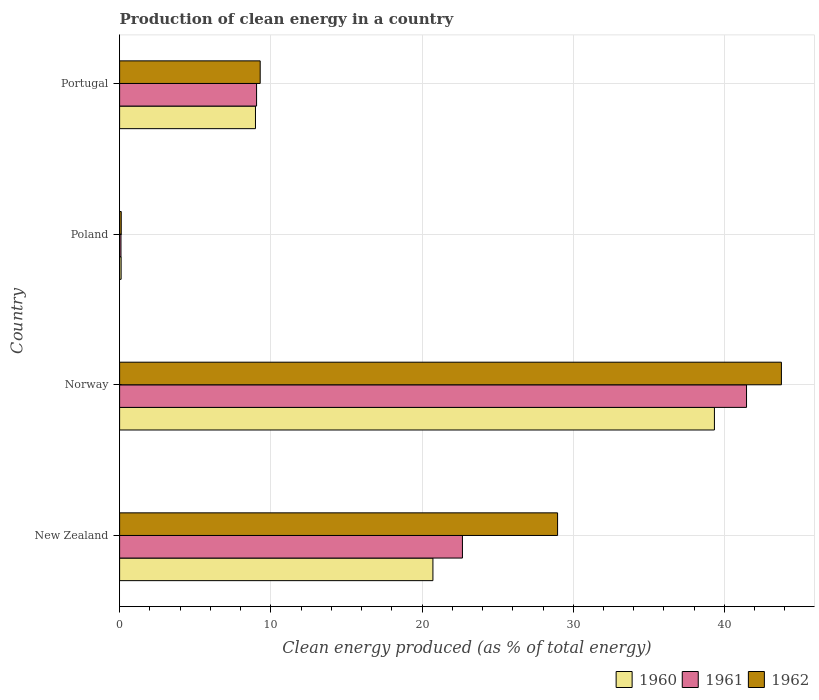How many different coloured bars are there?
Your response must be concise. 3. How many groups of bars are there?
Provide a succinct answer. 4. How many bars are there on the 4th tick from the top?
Your answer should be compact. 3. How many bars are there on the 3rd tick from the bottom?
Give a very brief answer. 3. What is the label of the 2nd group of bars from the top?
Keep it short and to the point. Poland. In how many cases, is the number of bars for a given country not equal to the number of legend labels?
Give a very brief answer. 0. What is the percentage of clean energy produced in 1961 in Norway?
Provide a succinct answer. 41.46. Across all countries, what is the maximum percentage of clean energy produced in 1962?
Provide a succinct answer. 43.77. Across all countries, what is the minimum percentage of clean energy produced in 1960?
Your response must be concise. 0.1. In which country was the percentage of clean energy produced in 1960 maximum?
Give a very brief answer. Norway. What is the total percentage of clean energy produced in 1962 in the graph?
Give a very brief answer. 82.13. What is the difference between the percentage of clean energy produced in 1960 in New Zealand and that in Portugal?
Your response must be concise. 11.74. What is the difference between the percentage of clean energy produced in 1961 in New Zealand and the percentage of clean energy produced in 1960 in Norway?
Your answer should be very brief. -16.66. What is the average percentage of clean energy produced in 1960 per country?
Provide a short and direct response. 17.29. What is the difference between the percentage of clean energy produced in 1962 and percentage of clean energy produced in 1961 in Portugal?
Offer a terse response. 0.24. What is the ratio of the percentage of clean energy produced in 1961 in New Zealand to that in Portugal?
Make the answer very short. 2.5. What is the difference between the highest and the second highest percentage of clean energy produced in 1962?
Offer a terse response. 14.8. What is the difference between the highest and the lowest percentage of clean energy produced in 1962?
Ensure brevity in your answer.  43.66. In how many countries, is the percentage of clean energy produced in 1960 greater than the average percentage of clean energy produced in 1960 taken over all countries?
Give a very brief answer. 2. Is the sum of the percentage of clean energy produced in 1962 in Norway and Poland greater than the maximum percentage of clean energy produced in 1961 across all countries?
Ensure brevity in your answer.  Yes. What does the 3rd bar from the bottom in Poland represents?
Keep it short and to the point. 1962. Are all the bars in the graph horizontal?
Provide a short and direct response. Yes. How many countries are there in the graph?
Make the answer very short. 4. How many legend labels are there?
Offer a terse response. 3. What is the title of the graph?
Provide a succinct answer. Production of clean energy in a country. Does "1999" appear as one of the legend labels in the graph?
Make the answer very short. No. What is the label or title of the X-axis?
Give a very brief answer. Clean energy produced (as % of total energy). What is the Clean energy produced (as % of total energy) of 1960 in New Zealand?
Your response must be concise. 20.72. What is the Clean energy produced (as % of total energy) in 1961 in New Zealand?
Keep it short and to the point. 22.67. What is the Clean energy produced (as % of total energy) in 1962 in New Zealand?
Make the answer very short. 28.96. What is the Clean energy produced (as % of total energy) of 1960 in Norway?
Your answer should be compact. 39.34. What is the Clean energy produced (as % of total energy) in 1961 in Norway?
Keep it short and to the point. 41.46. What is the Clean energy produced (as % of total energy) in 1962 in Norway?
Your answer should be compact. 43.77. What is the Clean energy produced (as % of total energy) in 1960 in Poland?
Your answer should be compact. 0.1. What is the Clean energy produced (as % of total energy) in 1961 in Poland?
Your answer should be compact. 0.09. What is the Clean energy produced (as % of total energy) in 1962 in Poland?
Keep it short and to the point. 0.11. What is the Clean energy produced (as % of total energy) in 1960 in Portugal?
Offer a very short reply. 8.99. What is the Clean energy produced (as % of total energy) of 1961 in Portugal?
Provide a succinct answer. 9.06. What is the Clean energy produced (as % of total energy) of 1962 in Portugal?
Provide a short and direct response. 9.3. Across all countries, what is the maximum Clean energy produced (as % of total energy) in 1960?
Make the answer very short. 39.34. Across all countries, what is the maximum Clean energy produced (as % of total energy) of 1961?
Keep it short and to the point. 41.46. Across all countries, what is the maximum Clean energy produced (as % of total energy) of 1962?
Provide a short and direct response. 43.77. Across all countries, what is the minimum Clean energy produced (as % of total energy) in 1960?
Ensure brevity in your answer.  0.1. Across all countries, what is the minimum Clean energy produced (as % of total energy) of 1961?
Provide a succinct answer. 0.09. Across all countries, what is the minimum Clean energy produced (as % of total energy) of 1962?
Make the answer very short. 0.11. What is the total Clean energy produced (as % of total energy) in 1960 in the graph?
Your response must be concise. 69.14. What is the total Clean energy produced (as % of total energy) in 1961 in the graph?
Your answer should be compact. 73.28. What is the total Clean energy produced (as % of total energy) of 1962 in the graph?
Give a very brief answer. 82.13. What is the difference between the Clean energy produced (as % of total energy) in 1960 in New Zealand and that in Norway?
Offer a terse response. -18.62. What is the difference between the Clean energy produced (as % of total energy) in 1961 in New Zealand and that in Norway?
Offer a very short reply. -18.79. What is the difference between the Clean energy produced (as % of total energy) in 1962 in New Zealand and that in Norway?
Give a very brief answer. -14.8. What is the difference between the Clean energy produced (as % of total energy) in 1960 in New Zealand and that in Poland?
Your response must be concise. 20.62. What is the difference between the Clean energy produced (as % of total energy) of 1961 in New Zealand and that in Poland?
Keep it short and to the point. 22.58. What is the difference between the Clean energy produced (as % of total energy) in 1962 in New Zealand and that in Poland?
Your answer should be compact. 28.86. What is the difference between the Clean energy produced (as % of total energy) of 1960 in New Zealand and that in Portugal?
Make the answer very short. 11.74. What is the difference between the Clean energy produced (as % of total energy) in 1961 in New Zealand and that in Portugal?
Offer a very short reply. 13.61. What is the difference between the Clean energy produced (as % of total energy) in 1962 in New Zealand and that in Portugal?
Provide a succinct answer. 19.67. What is the difference between the Clean energy produced (as % of total energy) in 1960 in Norway and that in Poland?
Ensure brevity in your answer.  39.24. What is the difference between the Clean energy produced (as % of total energy) of 1961 in Norway and that in Poland?
Give a very brief answer. 41.37. What is the difference between the Clean energy produced (as % of total energy) of 1962 in Norway and that in Poland?
Your response must be concise. 43.66. What is the difference between the Clean energy produced (as % of total energy) of 1960 in Norway and that in Portugal?
Keep it short and to the point. 30.35. What is the difference between the Clean energy produced (as % of total energy) in 1961 in Norway and that in Portugal?
Give a very brief answer. 32.4. What is the difference between the Clean energy produced (as % of total energy) in 1962 in Norway and that in Portugal?
Provide a short and direct response. 34.47. What is the difference between the Clean energy produced (as % of total energy) in 1960 in Poland and that in Portugal?
Offer a terse response. -8.88. What is the difference between the Clean energy produced (as % of total energy) of 1961 in Poland and that in Portugal?
Provide a short and direct response. -8.97. What is the difference between the Clean energy produced (as % of total energy) of 1962 in Poland and that in Portugal?
Make the answer very short. -9.19. What is the difference between the Clean energy produced (as % of total energy) of 1960 in New Zealand and the Clean energy produced (as % of total energy) of 1961 in Norway?
Provide a short and direct response. -20.74. What is the difference between the Clean energy produced (as % of total energy) in 1960 in New Zealand and the Clean energy produced (as % of total energy) in 1962 in Norway?
Offer a terse response. -23.05. What is the difference between the Clean energy produced (as % of total energy) in 1961 in New Zealand and the Clean energy produced (as % of total energy) in 1962 in Norway?
Make the answer very short. -21.09. What is the difference between the Clean energy produced (as % of total energy) of 1960 in New Zealand and the Clean energy produced (as % of total energy) of 1961 in Poland?
Your answer should be compact. 20.63. What is the difference between the Clean energy produced (as % of total energy) in 1960 in New Zealand and the Clean energy produced (as % of total energy) in 1962 in Poland?
Provide a short and direct response. 20.61. What is the difference between the Clean energy produced (as % of total energy) in 1961 in New Zealand and the Clean energy produced (as % of total energy) in 1962 in Poland?
Give a very brief answer. 22.56. What is the difference between the Clean energy produced (as % of total energy) in 1960 in New Zealand and the Clean energy produced (as % of total energy) in 1961 in Portugal?
Provide a succinct answer. 11.66. What is the difference between the Clean energy produced (as % of total energy) in 1960 in New Zealand and the Clean energy produced (as % of total energy) in 1962 in Portugal?
Offer a terse response. 11.42. What is the difference between the Clean energy produced (as % of total energy) of 1961 in New Zealand and the Clean energy produced (as % of total energy) of 1962 in Portugal?
Offer a terse response. 13.38. What is the difference between the Clean energy produced (as % of total energy) of 1960 in Norway and the Clean energy produced (as % of total energy) of 1961 in Poland?
Keep it short and to the point. 39.24. What is the difference between the Clean energy produced (as % of total energy) in 1960 in Norway and the Clean energy produced (as % of total energy) in 1962 in Poland?
Make the answer very short. 39.23. What is the difference between the Clean energy produced (as % of total energy) in 1961 in Norway and the Clean energy produced (as % of total energy) in 1962 in Poland?
Provide a short and direct response. 41.35. What is the difference between the Clean energy produced (as % of total energy) in 1960 in Norway and the Clean energy produced (as % of total energy) in 1961 in Portugal?
Your answer should be very brief. 30.28. What is the difference between the Clean energy produced (as % of total energy) in 1960 in Norway and the Clean energy produced (as % of total energy) in 1962 in Portugal?
Give a very brief answer. 30.04. What is the difference between the Clean energy produced (as % of total energy) of 1961 in Norway and the Clean energy produced (as % of total energy) of 1962 in Portugal?
Ensure brevity in your answer.  32.16. What is the difference between the Clean energy produced (as % of total energy) of 1960 in Poland and the Clean energy produced (as % of total energy) of 1961 in Portugal?
Provide a short and direct response. -8.96. What is the difference between the Clean energy produced (as % of total energy) of 1960 in Poland and the Clean energy produced (as % of total energy) of 1962 in Portugal?
Your answer should be very brief. -9.2. What is the difference between the Clean energy produced (as % of total energy) of 1961 in Poland and the Clean energy produced (as % of total energy) of 1962 in Portugal?
Make the answer very short. -9.21. What is the average Clean energy produced (as % of total energy) of 1960 per country?
Ensure brevity in your answer.  17.29. What is the average Clean energy produced (as % of total energy) in 1961 per country?
Make the answer very short. 18.32. What is the average Clean energy produced (as % of total energy) in 1962 per country?
Give a very brief answer. 20.53. What is the difference between the Clean energy produced (as % of total energy) in 1960 and Clean energy produced (as % of total energy) in 1961 in New Zealand?
Offer a very short reply. -1.95. What is the difference between the Clean energy produced (as % of total energy) of 1960 and Clean energy produced (as % of total energy) of 1962 in New Zealand?
Give a very brief answer. -8.24. What is the difference between the Clean energy produced (as % of total energy) in 1961 and Clean energy produced (as % of total energy) in 1962 in New Zealand?
Offer a terse response. -6.29. What is the difference between the Clean energy produced (as % of total energy) in 1960 and Clean energy produced (as % of total energy) in 1961 in Norway?
Keep it short and to the point. -2.12. What is the difference between the Clean energy produced (as % of total energy) in 1960 and Clean energy produced (as % of total energy) in 1962 in Norway?
Offer a terse response. -4.43. What is the difference between the Clean energy produced (as % of total energy) of 1961 and Clean energy produced (as % of total energy) of 1962 in Norway?
Your answer should be very brief. -2.31. What is the difference between the Clean energy produced (as % of total energy) in 1960 and Clean energy produced (as % of total energy) in 1961 in Poland?
Provide a short and direct response. 0.01. What is the difference between the Clean energy produced (as % of total energy) of 1960 and Clean energy produced (as % of total energy) of 1962 in Poland?
Keep it short and to the point. -0.01. What is the difference between the Clean energy produced (as % of total energy) of 1961 and Clean energy produced (as % of total energy) of 1962 in Poland?
Your answer should be very brief. -0.02. What is the difference between the Clean energy produced (as % of total energy) in 1960 and Clean energy produced (as % of total energy) in 1961 in Portugal?
Make the answer very short. -0.07. What is the difference between the Clean energy produced (as % of total energy) of 1960 and Clean energy produced (as % of total energy) of 1962 in Portugal?
Offer a terse response. -0.31. What is the difference between the Clean energy produced (as % of total energy) in 1961 and Clean energy produced (as % of total energy) in 1962 in Portugal?
Your answer should be compact. -0.24. What is the ratio of the Clean energy produced (as % of total energy) of 1960 in New Zealand to that in Norway?
Ensure brevity in your answer.  0.53. What is the ratio of the Clean energy produced (as % of total energy) of 1961 in New Zealand to that in Norway?
Provide a succinct answer. 0.55. What is the ratio of the Clean energy produced (as % of total energy) in 1962 in New Zealand to that in Norway?
Your response must be concise. 0.66. What is the ratio of the Clean energy produced (as % of total energy) of 1960 in New Zealand to that in Poland?
Give a very brief answer. 206.53. What is the ratio of the Clean energy produced (as % of total energy) in 1961 in New Zealand to that in Poland?
Your answer should be very brief. 247.72. What is the ratio of the Clean energy produced (as % of total energy) of 1962 in New Zealand to that in Poland?
Your answer should be very brief. 267.62. What is the ratio of the Clean energy produced (as % of total energy) of 1960 in New Zealand to that in Portugal?
Make the answer very short. 2.31. What is the ratio of the Clean energy produced (as % of total energy) in 1961 in New Zealand to that in Portugal?
Keep it short and to the point. 2.5. What is the ratio of the Clean energy produced (as % of total energy) in 1962 in New Zealand to that in Portugal?
Your answer should be compact. 3.12. What is the ratio of the Clean energy produced (as % of total energy) of 1960 in Norway to that in Poland?
Provide a short and direct response. 392.08. What is the ratio of the Clean energy produced (as % of total energy) in 1961 in Norway to that in Poland?
Offer a very short reply. 452.99. What is the ratio of the Clean energy produced (as % of total energy) in 1962 in Norway to that in Poland?
Ensure brevity in your answer.  404.39. What is the ratio of the Clean energy produced (as % of total energy) in 1960 in Norway to that in Portugal?
Your answer should be very brief. 4.38. What is the ratio of the Clean energy produced (as % of total energy) of 1961 in Norway to that in Portugal?
Keep it short and to the point. 4.58. What is the ratio of the Clean energy produced (as % of total energy) in 1962 in Norway to that in Portugal?
Your response must be concise. 4.71. What is the ratio of the Clean energy produced (as % of total energy) in 1960 in Poland to that in Portugal?
Ensure brevity in your answer.  0.01. What is the ratio of the Clean energy produced (as % of total energy) in 1961 in Poland to that in Portugal?
Offer a very short reply. 0.01. What is the ratio of the Clean energy produced (as % of total energy) of 1962 in Poland to that in Portugal?
Give a very brief answer. 0.01. What is the difference between the highest and the second highest Clean energy produced (as % of total energy) of 1960?
Give a very brief answer. 18.62. What is the difference between the highest and the second highest Clean energy produced (as % of total energy) in 1961?
Provide a short and direct response. 18.79. What is the difference between the highest and the second highest Clean energy produced (as % of total energy) of 1962?
Your answer should be very brief. 14.8. What is the difference between the highest and the lowest Clean energy produced (as % of total energy) in 1960?
Give a very brief answer. 39.24. What is the difference between the highest and the lowest Clean energy produced (as % of total energy) in 1961?
Make the answer very short. 41.37. What is the difference between the highest and the lowest Clean energy produced (as % of total energy) in 1962?
Offer a very short reply. 43.66. 